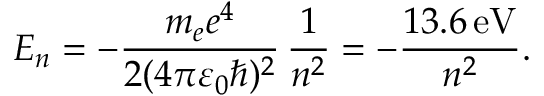<formula> <loc_0><loc_0><loc_500><loc_500>E _ { n } = - { \frac { m _ { e } e ^ { 4 } } { 2 ( 4 \pi \varepsilon _ { 0 } \hbar { ) } ^ { 2 } } } \, { \frac { 1 } { n ^ { 2 } } } = - { \frac { 1 3 . 6 \, { e V } } { n ^ { 2 } } } .</formula> 